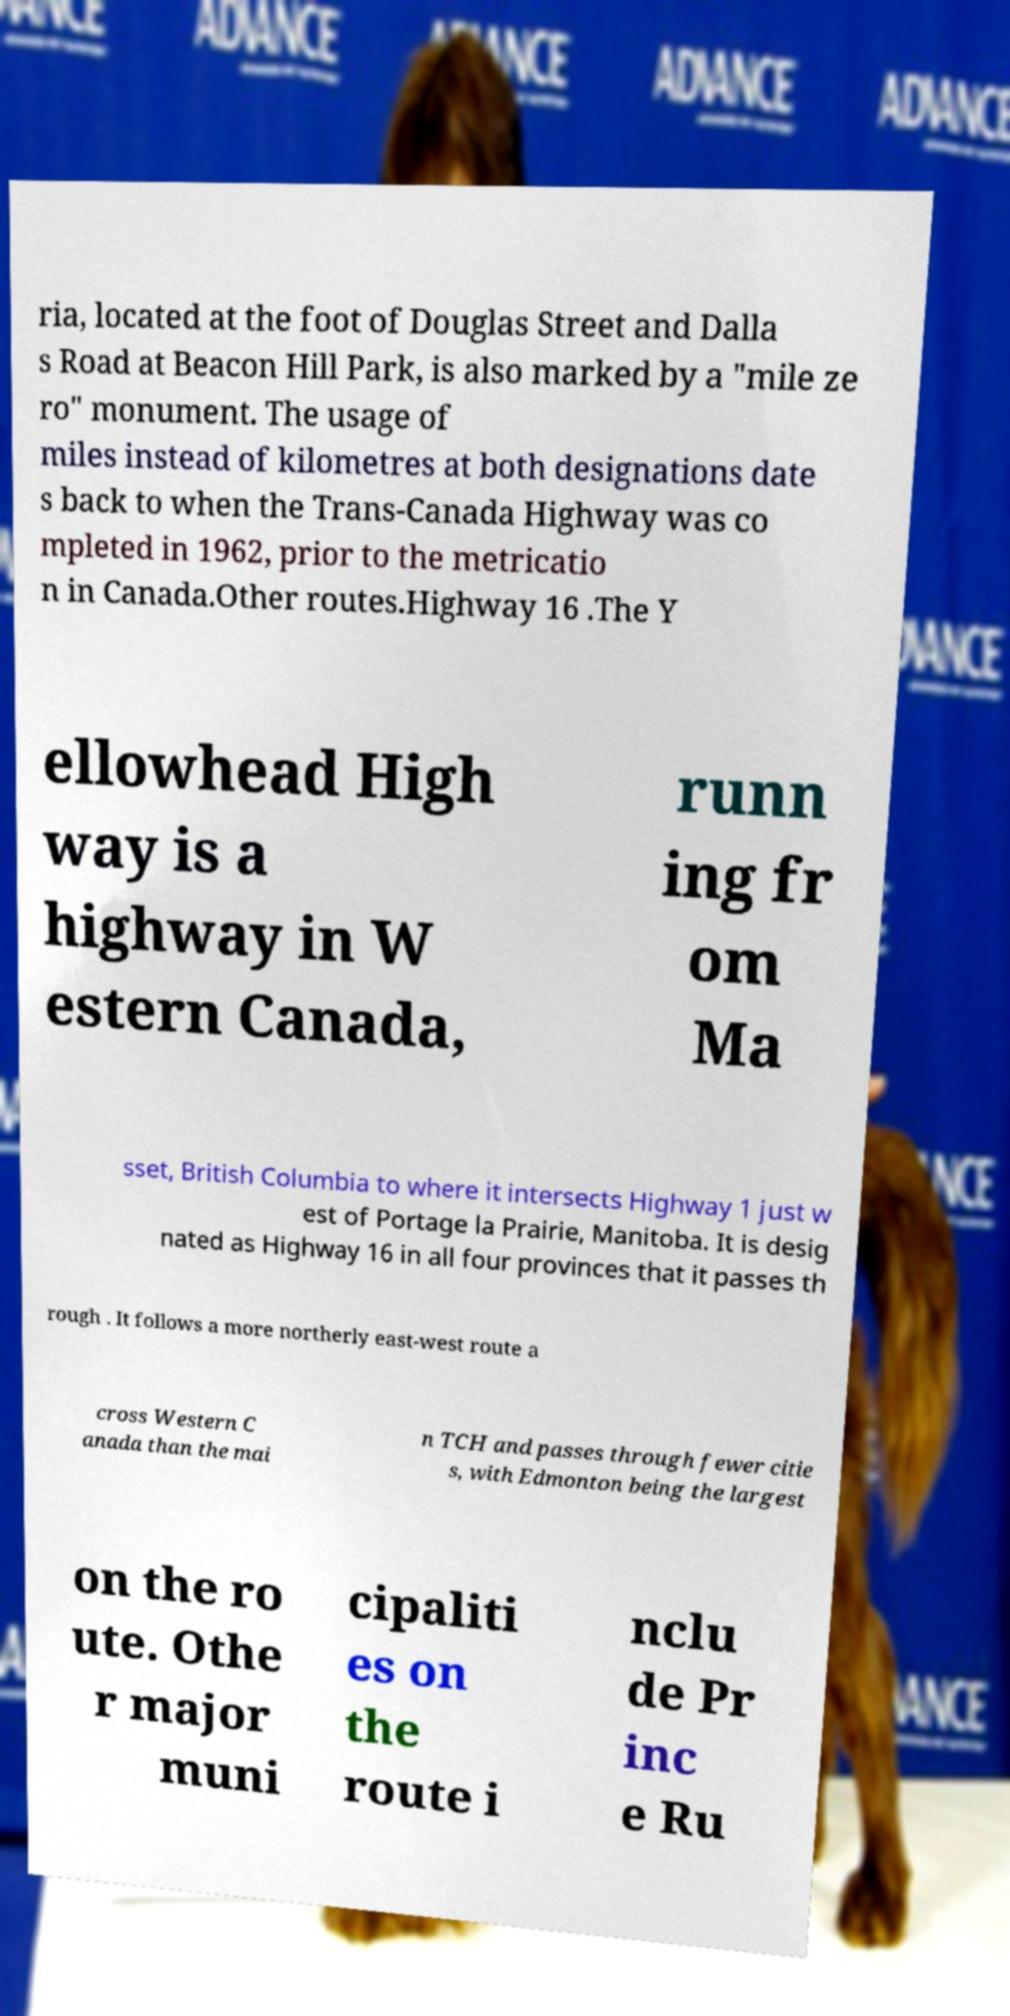Please read and relay the text visible in this image. What does it say? ria, located at the foot of Douglas Street and Dalla s Road at Beacon Hill Park, is also marked by a "mile ze ro" monument. The usage of miles instead of kilometres at both designations date s back to when the Trans-Canada Highway was co mpleted in 1962, prior to the metricatio n in Canada.Other routes.Highway 16 .The Y ellowhead High way is a highway in W estern Canada, runn ing fr om Ma sset, British Columbia to where it intersects Highway 1 just w est of Portage la Prairie, Manitoba. It is desig nated as Highway 16 in all four provinces that it passes th rough . It follows a more northerly east-west route a cross Western C anada than the mai n TCH and passes through fewer citie s, with Edmonton being the largest on the ro ute. Othe r major muni cipaliti es on the route i nclu de Pr inc e Ru 